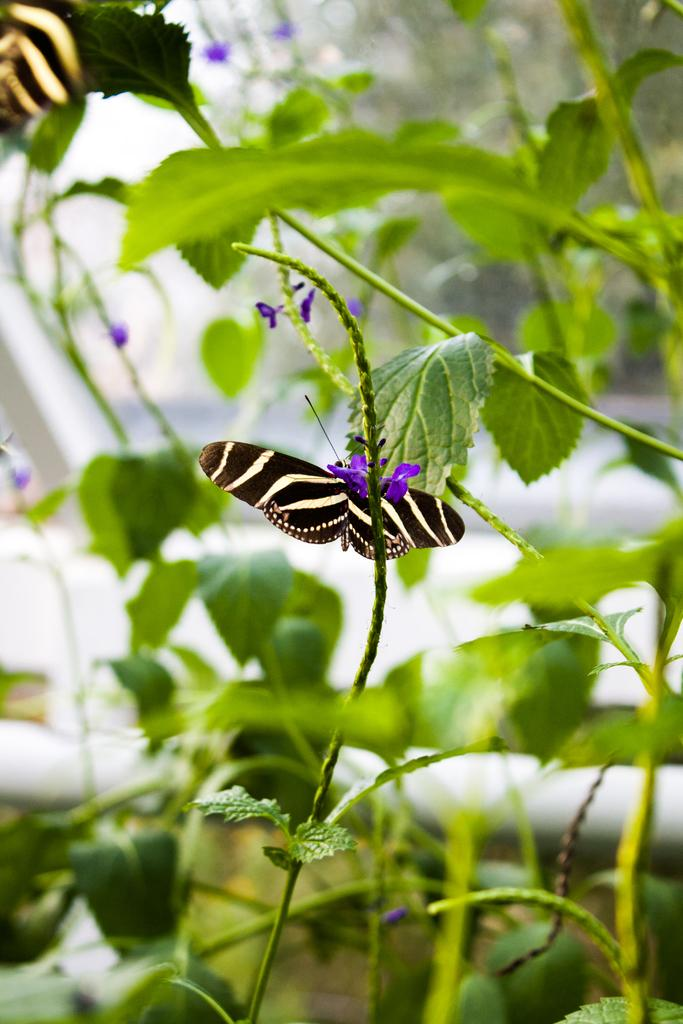What type of living organisms can be seen in the image? Insects can be seen in the image. What other elements are present in the image besides insects? Plants, flowers, and objects are present in the image. Can you describe the plants in the image? The plants in the image have flowers. How would you characterize the objects in the image? The objects in the image are unspecified, but they are present. What can be said about the background of the image? The background of the image is blurry. What type of orange is being used as a station in the image? There is no orange or station present in the image. 